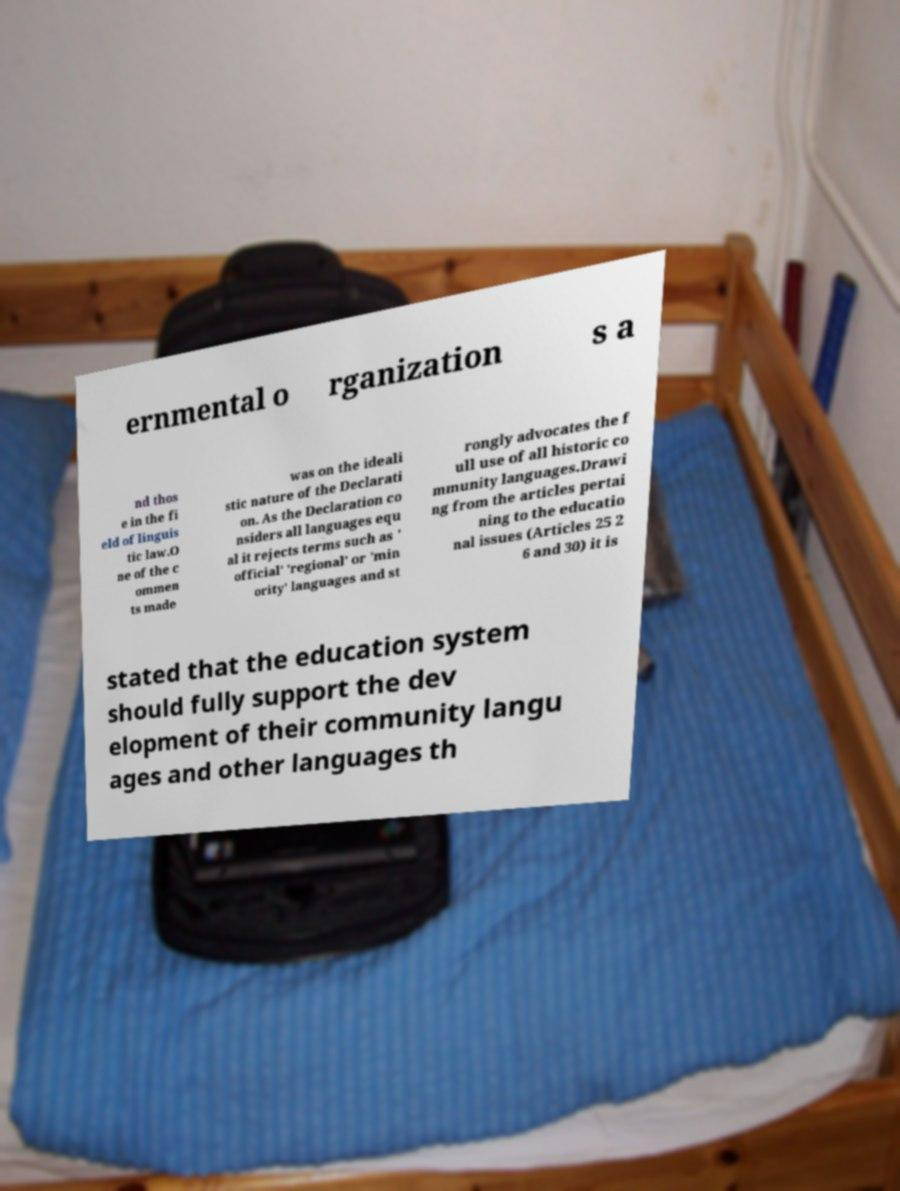For documentation purposes, I need the text within this image transcribed. Could you provide that? ernmental o rganization s a nd thos e in the fi eld of linguis tic law.O ne of the c ommen ts made was on the ideali stic nature of the Declarati on. As the Declaration co nsiders all languages equ al it rejects terms such as ' official' 'regional' or 'min ority' languages and st rongly advocates the f ull use of all historic co mmunity languages.Drawi ng from the articles pertai ning to the educatio nal issues (Articles 25 2 6 and 30) it is stated that the education system should fully support the dev elopment of their community langu ages and other languages th 